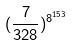Convert formula to latex. <formula><loc_0><loc_0><loc_500><loc_500>( \frac { 7 } { 3 2 8 } ) ^ { 8 ^ { 1 5 3 } }</formula> 